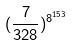Convert formula to latex. <formula><loc_0><loc_0><loc_500><loc_500>( \frac { 7 } { 3 2 8 } ) ^ { 8 ^ { 1 5 3 } }</formula> 